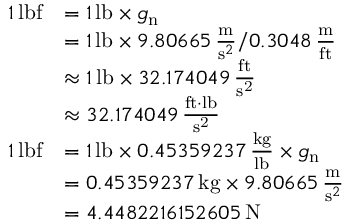<formula> <loc_0><loc_0><loc_500><loc_500>{ \begin{array} { r l } { 1 \, { l b f } } & { = 1 \, { l b } \times g _ { n } } \\ & { = 1 \, { l b } \times 9 . 8 0 6 6 5 \, { \frac { m } { { s } ^ { 2 } } } / 0 . 3 0 4 8 \, { \frac { m } { f t } } } \\ & { \approx 1 \, { l b } \times 3 2 . 1 7 4 0 4 9 \, \frac { f t } { s ^ { 2 } } } \\ & { \approx 3 2 . 1 7 4 0 4 9 \, \frac { f t { \cdot } l b } { s ^ { 2 } } } \\ { 1 \, { l b f } } & { = 1 \, { l b } \times 0 . 4 5 3 5 9 2 3 7 \, { \frac { k g } { l b } } \times g _ { n } } \\ & { = 0 . 4 5 3 5 9 2 3 7 \, { k g } \times 9 . 8 0 6 6 5 \, { \frac { m } { { s } ^ { 2 } } } } \\ & { = 4 . 4 4 8 2 2 1 6 1 5 2 6 0 5 \, { N } } \end{array} }</formula> 